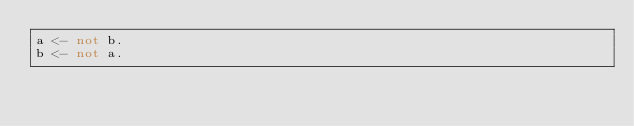<code> <loc_0><loc_0><loc_500><loc_500><_Prolog_>a <- not b.
b <- not a.
</code> 